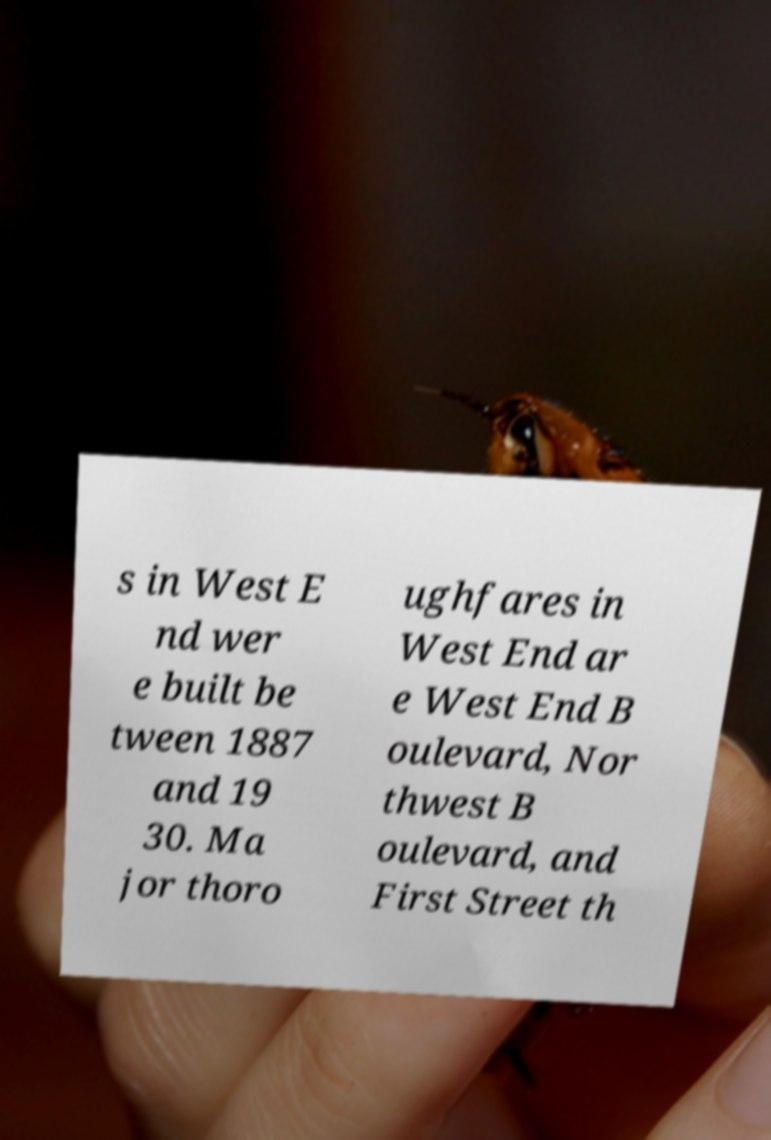Please read and relay the text visible in this image. What does it say? s in West E nd wer e built be tween 1887 and 19 30. Ma jor thoro ughfares in West End ar e West End B oulevard, Nor thwest B oulevard, and First Street th 